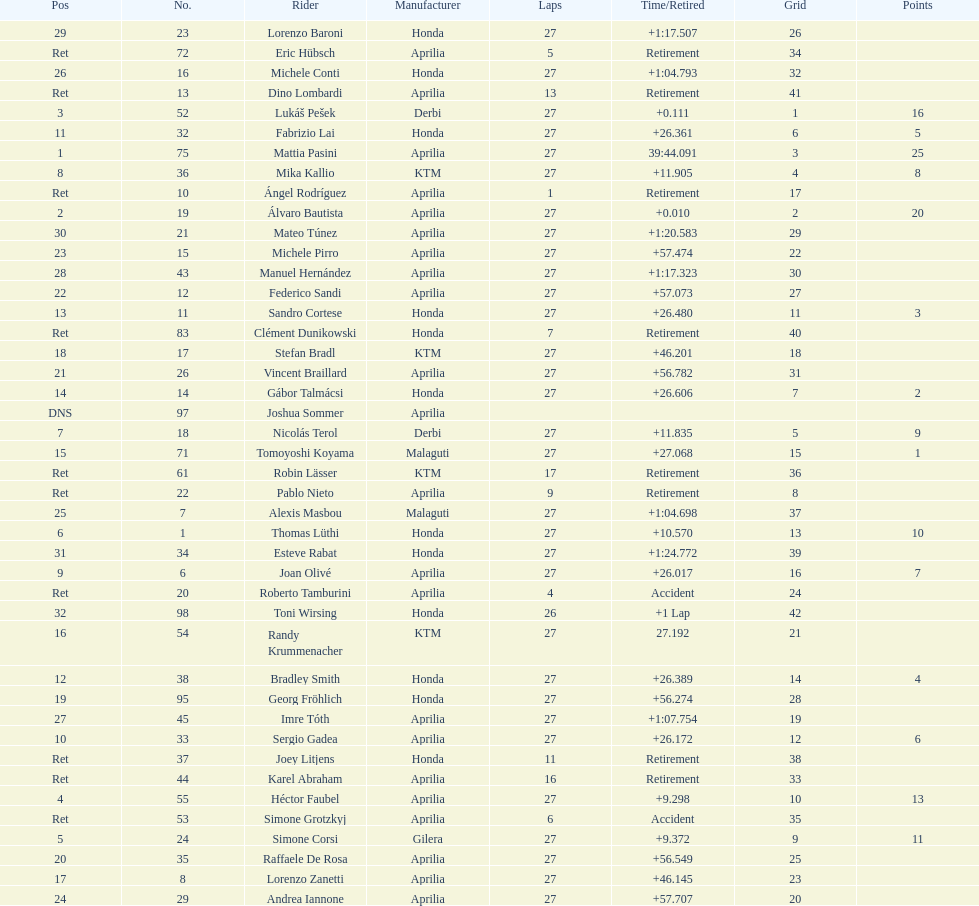Can you parse all the data within this table? {'header': ['Pos', 'No.', 'Rider', 'Manufacturer', 'Laps', 'Time/Retired', 'Grid', 'Points'], 'rows': [['29', '23', 'Lorenzo Baroni', 'Honda', '27', '+1:17.507', '26', ''], ['Ret', '72', 'Eric Hübsch', 'Aprilia', '5', 'Retirement', '34', ''], ['26', '16', 'Michele Conti', 'Honda', '27', '+1:04.793', '32', ''], ['Ret', '13', 'Dino Lombardi', 'Aprilia', '13', 'Retirement', '41', ''], ['3', '52', 'Lukáš Pešek', 'Derbi', '27', '+0.111', '1', '16'], ['11', '32', 'Fabrizio Lai', 'Honda', '27', '+26.361', '6', '5'], ['1', '75', 'Mattia Pasini', 'Aprilia', '27', '39:44.091', '3', '25'], ['8', '36', 'Mika Kallio', 'KTM', '27', '+11.905', '4', '8'], ['Ret', '10', 'Ángel Rodríguez', 'Aprilia', '1', 'Retirement', '17', ''], ['2', '19', 'Álvaro Bautista', 'Aprilia', '27', '+0.010', '2', '20'], ['30', '21', 'Mateo Túnez', 'Aprilia', '27', '+1:20.583', '29', ''], ['23', '15', 'Michele Pirro', 'Aprilia', '27', '+57.474', '22', ''], ['28', '43', 'Manuel Hernández', 'Aprilia', '27', '+1:17.323', '30', ''], ['22', '12', 'Federico Sandi', 'Aprilia', '27', '+57.073', '27', ''], ['13', '11', 'Sandro Cortese', 'Honda', '27', '+26.480', '11', '3'], ['Ret', '83', 'Clément Dunikowski', 'Honda', '7', 'Retirement', '40', ''], ['18', '17', 'Stefan Bradl', 'KTM', '27', '+46.201', '18', ''], ['21', '26', 'Vincent Braillard', 'Aprilia', '27', '+56.782', '31', ''], ['14', '14', 'Gábor Talmácsi', 'Honda', '27', '+26.606', '7', '2'], ['DNS', '97', 'Joshua Sommer', 'Aprilia', '', '', '', ''], ['7', '18', 'Nicolás Terol', 'Derbi', '27', '+11.835', '5', '9'], ['15', '71', 'Tomoyoshi Koyama', 'Malaguti', '27', '+27.068', '15', '1'], ['Ret', '61', 'Robin Lässer', 'KTM', '17', 'Retirement', '36', ''], ['Ret', '22', 'Pablo Nieto', 'Aprilia', '9', 'Retirement', '8', ''], ['25', '7', 'Alexis Masbou', 'Malaguti', '27', '+1:04.698', '37', ''], ['6', '1', 'Thomas Lüthi', 'Honda', '27', '+10.570', '13', '10'], ['31', '34', 'Esteve Rabat', 'Honda', '27', '+1:24.772', '39', ''], ['9', '6', 'Joan Olivé', 'Aprilia', '27', '+26.017', '16', '7'], ['Ret', '20', 'Roberto Tamburini', 'Aprilia', '4', 'Accident', '24', ''], ['32', '98', 'Toni Wirsing', 'Honda', '26', '+1 Lap', '42', ''], ['16', '54', 'Randy Krummenacher', 'KTM', '27', '27.192', '21', ''], ['12', '38', 'Bradley Smith', 'Honda', '27', '+26.389', '14', '4'], ['19', '95', 'Georg Fröhlich', 'Honda', '27', '+56.274', '28', ''], ['27', '45', 'Imre Tóth', 'Aprilia', '27', '+1:07.754', '19', ''], ['10', '33', 'Sergio Gadea', 'Aprilia', '27', '+26.172', '12', '6'], ['Ret', '37', 'Joey Litjens', 'Honda', '11', 'Retirement', '38', ''], ['Ret', '44', 'Karel Abraham', 'Aprilia', '16', 'Retirement', '33', ''], ['4', '55', 'Héctor Faubel', 'Aprilia', '27', '+9.298', '10', '13'], ['Ret', '53', 'Simone Grotzkyj', 'Aprilia', '6', 'Accident', '35', ''], ['5', '24', 'Simone Corsi', 'Gilera', '27', '+9.372', '9', '11'], ['20', '35', 'Raffaele De Rosa', 'Aprilia', '27', '+56.549', '25', ''], ['17', '8', 'Lorenzo Zanetti', 'Aprilia', '27', '+46.145', '23', ''], ['24', '29', 'Andrea Iannone', 'Aprilia', '27', '+57.707', '20', '']]} What was the total number of positions in the 125cc classification? 43. 